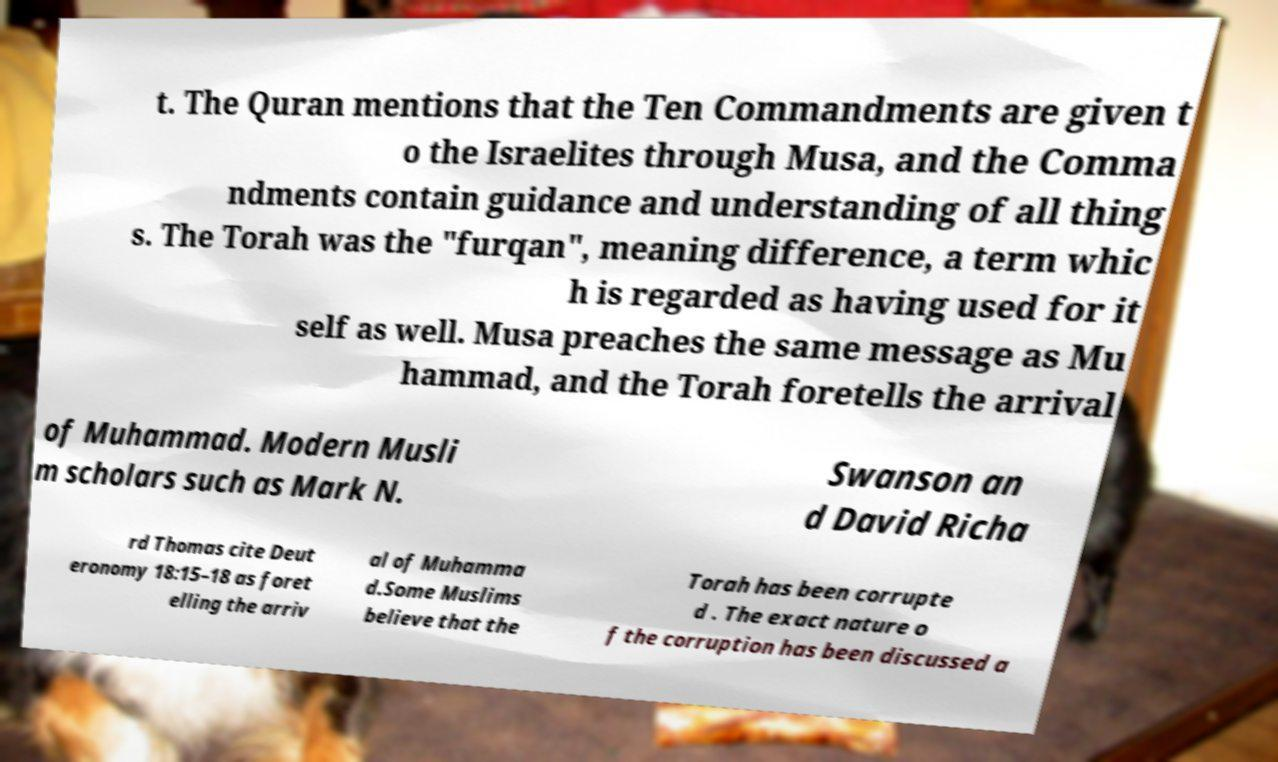Could you extract and type out the text from this image? t. The Quran mentions that the Ten Commandments are given t o the Israelites through Musa, and the Comma ndments contain guidance and understanding of all thing s. The Torah was the "furqan", meaning difference, a term whic h is regarded as having used for it self as well. Musa preaches the same message as Mu hammad, and the Torah foretells the arrival of Muhammad. Modern Musli m scholars such as Mark N. Swanson an d David Richa rd Thomas cite Deut eronomy 18:15–18 as foret elling the arriv al of Muhamma d.Some Muslims believe that the Torah has been corrupte d . The exact nature o f the corruption has been discussed a 